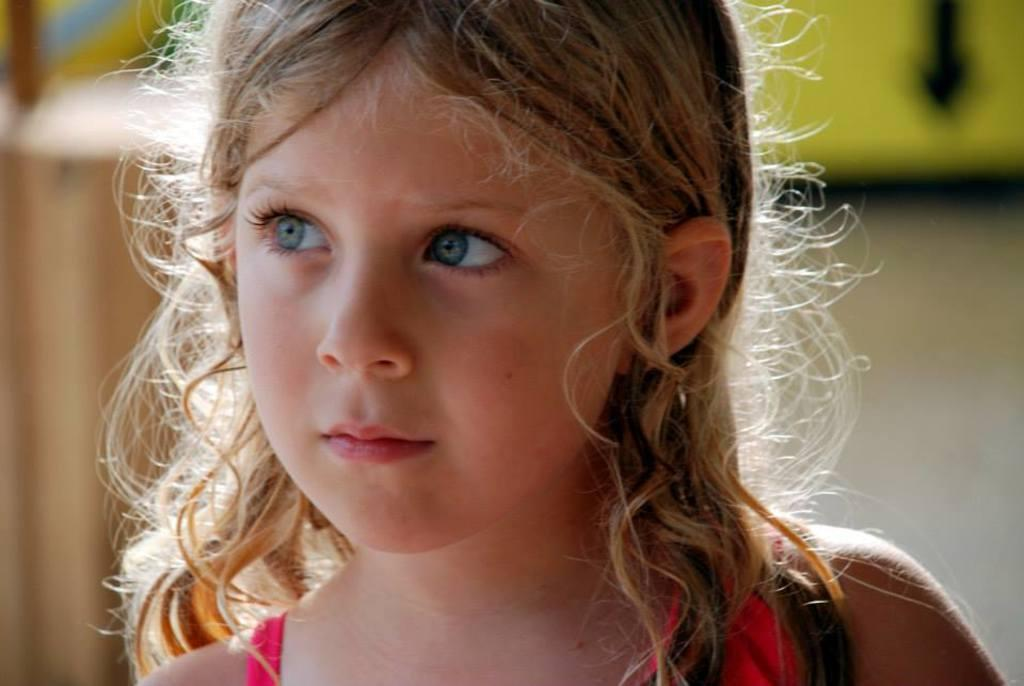Who is the main subject in the image? There is a girl in the image. Can you describe the girl's appearance? The girl has long hair and is wearing a pink dress. What is the girl's opinion on the need for more jokes in the image? The image does not depict the girl expressing an opinion or discussing jokes, so it is not possible to answer this question. 